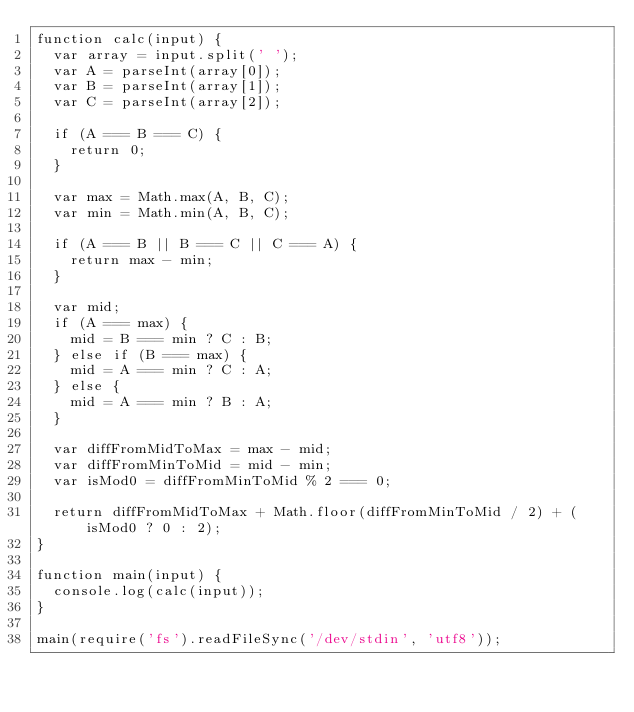Convert code to text. <code><loc_0><loc_0><loc_500><loc_500><_JavaScript_>function calc(input) {
  var array = input.split(' ');
  var A = parseInt(array[0]);
  var B = parseInt(array[1]);
  var C = parseInt(array[2]);

  if (A === B === C) {
    return 0;
  }

  var max = Math.max(A, B, C);
  var min = Math.min(A, B, C);

  if (A === B || B === C || C === A) {
    return max - min;
  }

  var mid;
  if (A === max) {
    mid = B === min ? C : B;
  } else if (B === max) {
    mid = A === min ? C : A;
  } else {
    mid = A === min ? B : A;
  }

  var diffFromMidToMax = max - mid;
  var diffFromMinToMid = mid - min;
  var isMod0 = diffFromMinToMid % 2 === 0;

  return diffFromMidToMax + Math.floor(diffFromMinToMid / 2) + (isMod0 ? 0 : 2);
}

function main(input) {
  console.log(calc(input));
}

main(require('fs').readFileSync('/dev/stdin', 'utf8'));</code> 